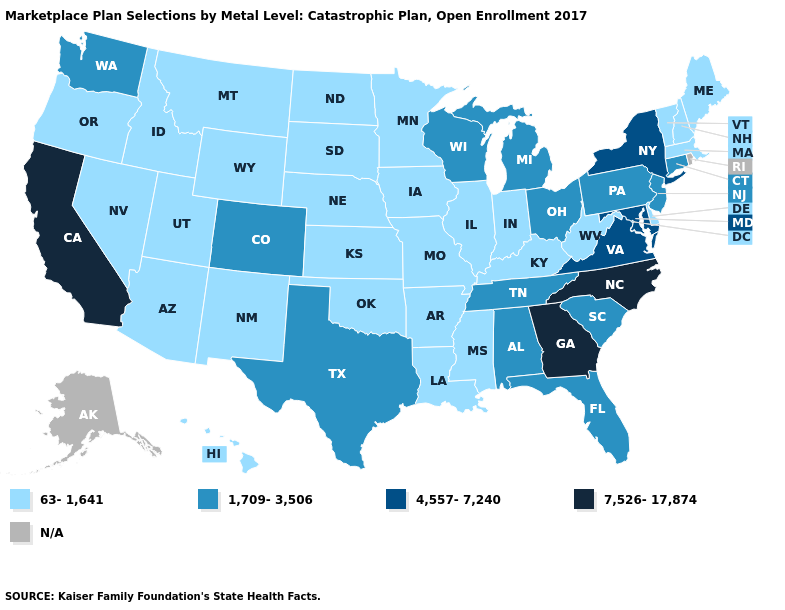What is the value of Florida?
Write a very short answer. 1,709-3,506. Name the states that have a value in the range 4,557-7,240?
Be succinct. Maryland, New York, Virginia. Does the map have missing data?
Short answer required. Yes. Does Hawaii have the highest value in the West?
Give a very brief answer. No. Name the states that have a value in the range 1,709-3,506?
Quick response, please. Alabama, Colorado, Connecticut, Florida, Michigan, New Jersey, Ohio, Pennsylvania, South Carolina, Tennessee, Texas, Washington, Wisconsin. Which states hav the highest value in the MidWest?
Short answer required. Michigan, Ohio, Wisconsin. Name the states that have a value in the range 1,709-3,506?
Answer briefly. Alabama, Colorado, Connecticut, Florida, Michigan, New Jersey, Ohio, Pennsylvania, South Carolina, Tennessee, Texas, Washington, Wisconsin. Does California have the lowest value in the USA?
Keep it brief. No. Does the map have missing data?
Short answer required. Yes. Name the states that have a value in the range 1,709-3,506?
Give a very brief answer. Alabama, Colorado, Connecticut, Florida, Michigan, New Jersey, Ohio, Pennsylvania, South Carolina, Tennessee, Texas, Washington, Wisconsin. Does California have the highest value in the West?
Answer briefly. Yes. Does New York have the highest value in the Northeast?
Concise answer only. Yes. What is the highest value in the USA?
Keep it brief. 7,526-17,874. 